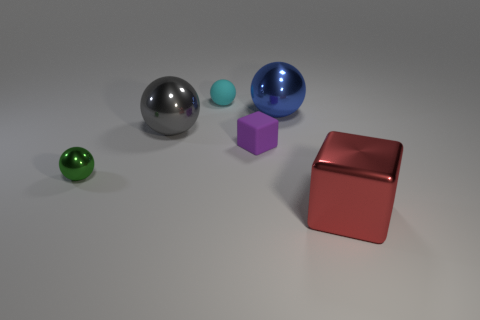Add 1 tiny blue metallic blocks. How many objects exist? 7 Subtract all balls. How many objects are left? 2 Add 2 rubber things. How many rubber things exist? 4 Subtract 1 red blocks. How many objects are left? 5 Subtract all blue cubes. Subtract all green spheres. How many objects are left? 5 Add 1 blue things. How many blue things are left? 2 